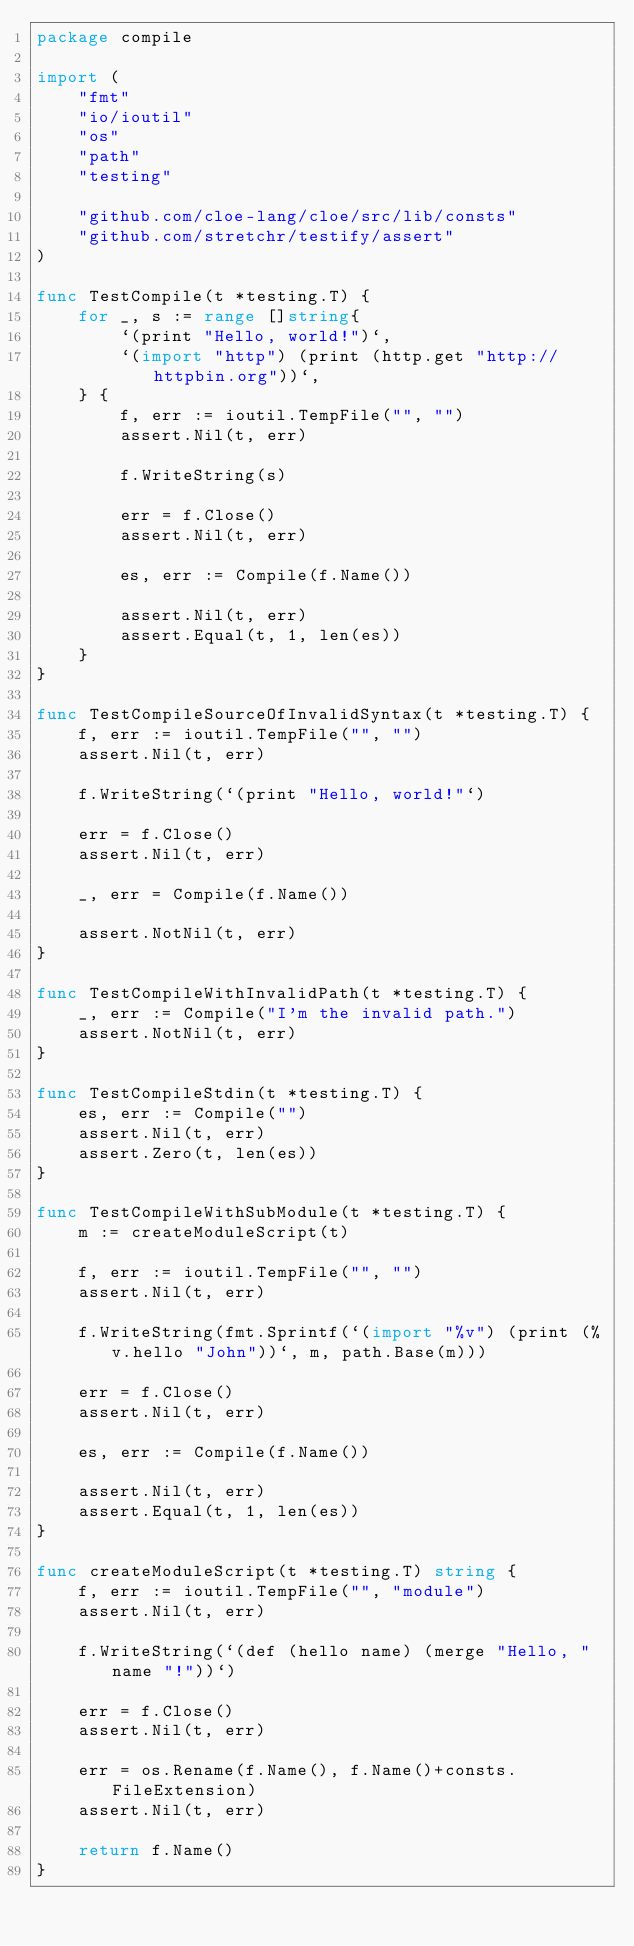<code> <loc_0><loc_0><loc_500><loc_500><_Go_>package compile

import (
	"fmt"
	"io/ioutil"
	"os"
	"path"
	"testing"

	"github.com/cloe-lang/cloe/src/lib/consts"
	"github.com/stretchr/testify/assert"
)

func TestCompile(t *testing.T) {
	for _, s := range []string{
		`(print "Hello, world!")`,
		`(import "http") (print (http.get "http://httpbin.org"))`,
	} {
		f, err := ioutil.TempFile("", "")
		assert.Nil(t, err)

		f.WriteString(s)

		err = f.Close()
		assert.Nil(t, err)

		es, err := Compile(f.Name())

		assert.Nil(t, err)
		assert.Equal(t, 1, len(es))
	}
}

func TestCompileSourceOfInvalidSyntax(t *testing.T) {
	f, err := ioutil.TempFile("", "")
	assert.Nil(t, err)

	f.WriteString(`(print "Hello, world!"`)

	err = f.Close()
	assert.Nil(t, err)

	_, err = Compile(f.Name())

	assert.NotNil(t, err)
}

func TestCompileWithInvalidPath(t *testing.T) {
	_, err := Compile("I'm the invalid path.")
	assert.NotNil(t, err)
}

func TestCompileStdin(t *testing.T) {
	es, err := Compile("")
	assert.Nil(t, err)
	assert.Zero(t, len(es))
}

func TestCompileWithSubModule(t *testing.T) {
	m := createModuleScript(t)

	f, err := ioutil.TempFile("", "")
	assert.Nil(t, err)

	f.WriteString(fmt.Sprintf(`(import "%v") (print (%v.hello "John"))`, m, path.Base(m)))

	err = f.Close()
	assert.Nil(t, err)

	es, err := Compile(f.Name())

	assert.Nil(t, err)
	assert.Equal(t, 1, len(es))
}

func createModuleScript(t *testing.T) string {
	f, err := ioutil.TempFile("", "module")
	assert.Nil(t, err)

	f.WriteString(`(def (hello name) (merge "Hello, " name "!"))`)

	err = f.Close()
	assert.Nil(t, err)

	err = os.Rename(f.Name(), f.Name()+consts.FileExtension)
	assert.Nil(t, err)

	return f.Name()
}
</code> 